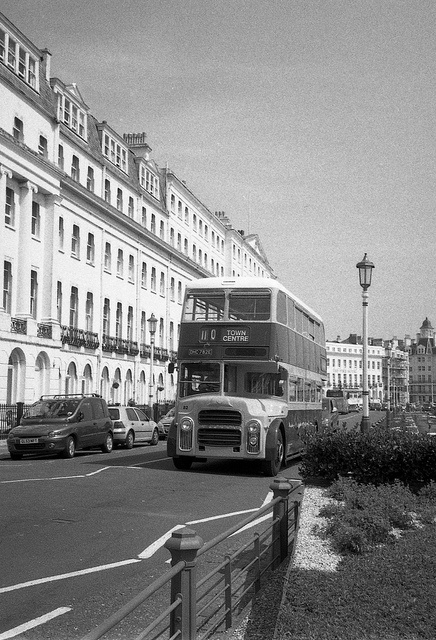Describe the objects in this image and their specific colors. I can see bus in gray, black, darkgray, and lightgray tones, car in gray, black, darkgray, and lightgray tones, car in gray, darkgray, black, and lightgray tones, and car in gray, darkgray, black, and lightgray tones in this image. 